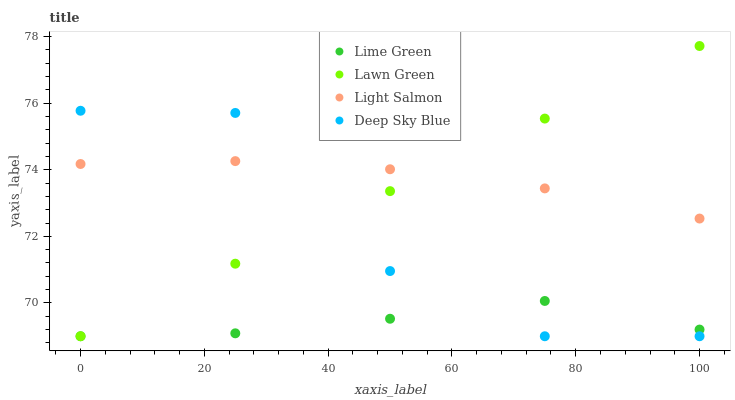Does Lime Green have the minimum area under the curve?
Answer yes or no. Yes. Does Light Salmon have the maximum area under the curve?
Answer yes or no. Yes. Does Light Salmon have the minimum area under the curve?
Answer yes or no. No. Does Lime Green have the maximum area under the curve?
Answer yes or no. No. Is Lawn Green the smoothest?
Answer yes or no. Yes. Is Deep Sky Blue the roughest?
Answer yes or no. Yes. Is Light Salmon the smoothest?
Answer yes or no. No. Is Light Salmon the roughest?
Answer yes or no. No. Does Lawn Green have the lowest value?
Answer yes or no. Yes. Does Light Salmon have the lowest value?
Answer yes or no. No. Does Lawn Green have the highest value?
Answer yes or no. Yes. Does Light Salmon have the highest value?
Answer yes or no. No. Is Lime Green less than Light Salmon?
Answer yes or no. Yes. Is Light Salmon greater than Lime Green?
Answer yes or no. Yes. Does Light Salmon intersect Deep Sky Blue?
Answer yes or no. Yes. Is Light Salmon less than Deep Sky Blue?
Answer yes or no. No. Is Light Salmon greater than Deep Sky Blue?
Answer yes or no. No. Does Lime Green intersect Light Salmon?
Answer yes or no. No. 